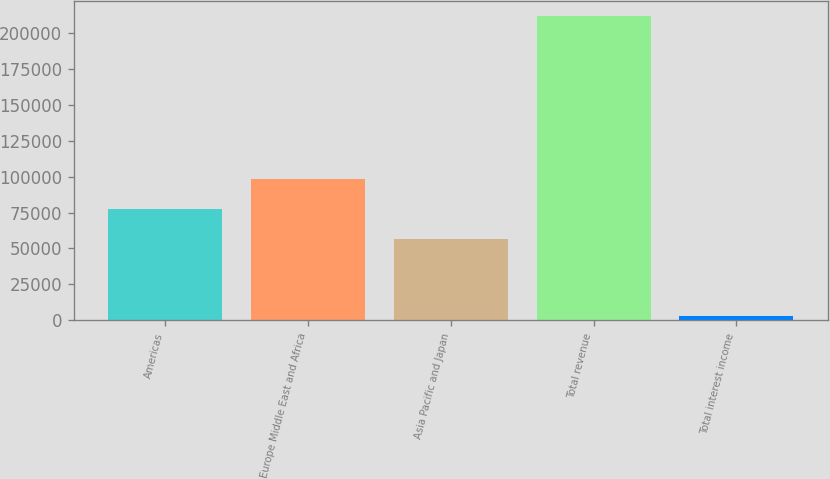Convert chart. <chart><loc_0><loc_0><loc_500><loc_500><bar_chart><fcel>Americas<fcel>Europe Middle East and Africa<fcel>Asia Pacific and Japan<fcel>Total revenue<fcel>Total interest income<nl><fcel>77586.7<fcel>98504.4<fcel>56669<fcel>211791<fcel>2614<nl></chart> 